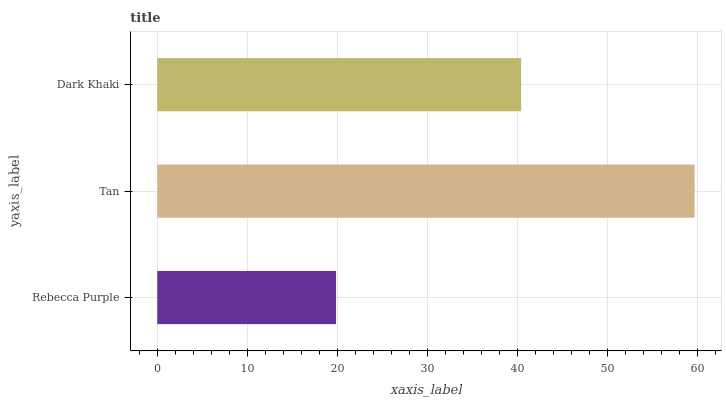Is Rebecca Purple the minimum?
Answer yes or no. Yes. Is Tan the maximum?
Answer yes or no. Yes. Is Dark Khaki the minimum?
Answer yes or no. No. Is Dark Khaki the maximum?
Answer yes or no. No. Is Tan greater than Dark Khaki?
Answer yes or no. Yes. Is Dark Khaki less than Tan?
Answer yes or no. Yes. Is Dark Khaki greater than Tan?
Answer yes or no. No. Is Tan less than Dark Khaki?
Answer yes or no. No. Is Dark Khaki the high median?
Answer yes or no. Yes. Is Dark Khaki the low median?
Answer yes or no. Yes. Is Tan the high median?
Answer yes or no. No. Is Tan the low median?
Answer yes or no. No. 